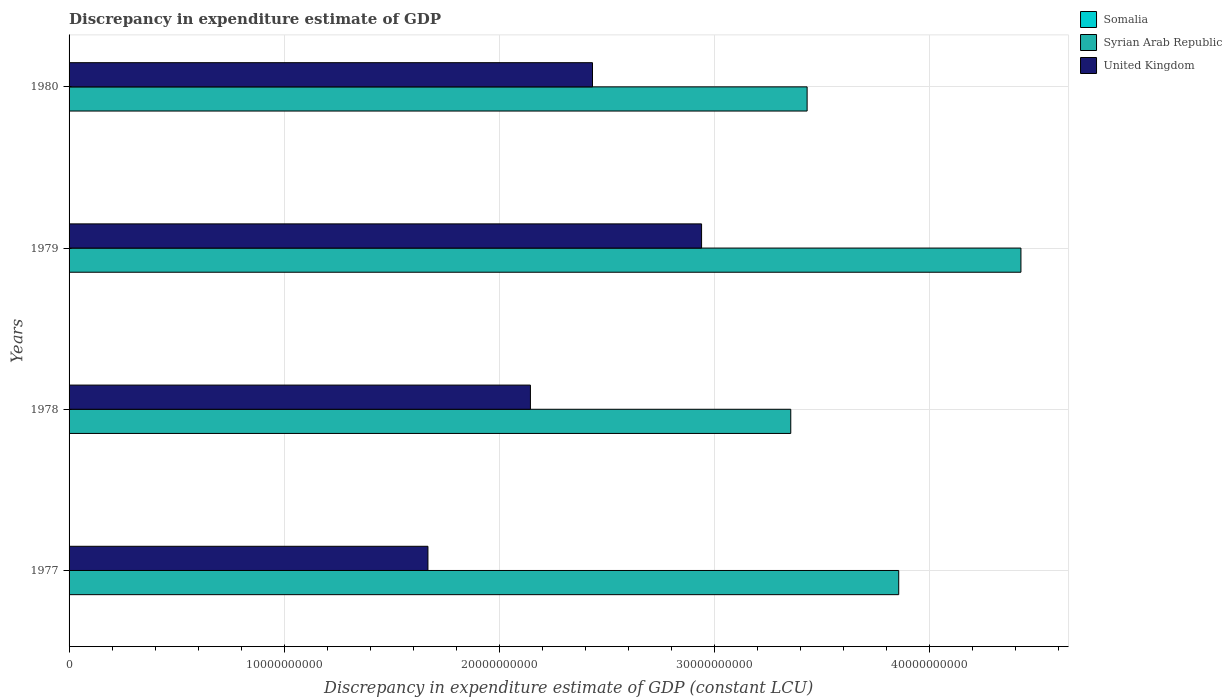How many groups of bars are there?
Keep it short and to the point. 4. Are the number of bars per tick equal to the number of legend labels?
Ensure brevity in your answer.  No. Are the number of bars on each tick of the Y-axis equal?
Make the answer very short. No. How many bars are there on the 3rd tick from the top?
Give a very brief answer. 3. How many bars are there on the 1st tick from the bottom?
Offer a very short reply. 2. What is the discrepancy in expenditure estimate of GDP in United Kingdom in 1977?
Keep it short and to the point. 1.67e+1. Across all years, what is the maximum discrepancy in expenditure estimate of GDP in Syrian Arab Republic?
Ensure brevity in your answer.  4.43e+1. Across all years, what is the minimum discrepancy in expenditure estimate of GDP in Syrian Arab Republic?
Your answer should be very brief. 3.36e+1. In which year was the discrepancy in expenditure estimate of GDP in Somalia maximum?
Your answer should be very brief. 1978. What is the total discrepancy in expenditure estimate of GDP in Syrian Arab Republic in the graph?
Your response must be concise. 1.51e+11. What is the difference between the discrepancy in expenditure estimate of GDP in Syrian Arab Republic in 1978 and that in 1979?
Keep it short and to the point. -1.07e+1. What is the difference between the discrepancy in expenditure estimate of GDP in United Kingdom in 1980 and the discrepancy in expenditure estimate of GDP in Somalia in 1978?
Offer a very short reply. 2.43e+1. What is the average discrepancy in expenditure estimate of GDP in United Kingdom per year?
Your response must be concise. 2.30e+1. In the year 1978, what is the difference between the discrepancy in expenditure estimate of GDP in Syrian Arab Republic and discrepancy in expenditure estimate of GDP in Somalia?
Offer a terse response. 3.36e+1. What is the ratio of the discrepancy in expenditure estimate of GDP in United Kingdom in 1978 to that in 1979?
Make the answer very short. 0.73. What is the difference between the highest and the second highest discrepancy in expenditure estimate of GDP in United Kingdom?
Provide a short and direct response. 5.07e+09. What is the difference between the highest and the lowest discrepancy in expenditure estimate of GDP in United Kingdom?
Your answer should be compact. 1.27e+1. How many bars are there?
Give a very brief answer. 10. Are all the bars in the graph horizontal?
Keep it short and to the point. Yes. What is the difference between two consecutive major ticks on the X-axis?
Provide a short and direct response. 1.00e+1. Are the values on the major ticks of X-axis written in scientific E-notation?
Give a very brief answer. No. Does the graph contain any zero values?
Provide a short and direct response. Yes. Where does the legend appear in the graph?
Your answer should be very brief. Top right. What is the title of the graph?
Make the answer very short. Discrepancy in expenditure estimate of GDP. Does "St. Vincent and the Grenadines" appear as one of the legend labels in the graph?
Make the answer very short. No. What is the label or title of the X-axis?
Keep it short and to the point. Discrepancy in expenditure estimate of GDP (constant LCU). What is the label or title of the Y-axis?
Provide a succinct answer. Years. What is the Discrepancy in expenditure estimate of GDP (constant LCU) in Somalia in 1977?
Your response must be concise. 0. What is the Discrepancy in expenditure estimate of GDP (constant LCU) of Syrian Arab Republic in 1977?
Your answer should be very brief. 3.86e+1. What is the Discrepancy in expenditure estimate of GDP (constant LCU) in United Kingdom in 1977?
Keep it short and to the point. 1.67e+1. What is the Discrepancy in expenditure estimate of GDP (constant LCU) of Somalia in 1978?
Offer a terse response. 1.05e+06. What is the Discrepancy in expenditure estimate of GDP (constant LCU) in Syrian Arab Republic in 1978?
Give a very brief answer. 3.36e+1. What is the Discrepancy in expenditure estimate of GDP (constant LCU) of United Kingdom in 1978?
Make the answer very short. 2.15e+1. What is the Discrepancy in expenditure estimate of GDP (constant LCU) of Somalia in 1979?
Your response must be concise. 1.01e+06. What is the Discrepancy in expenditure estimate of GDP (constant LCU) of Syrian Arab Republic in 1979?
Offer a terse response. 4.43e+1. What is the Discrepancy in expenditure estimate of GDP (constant LCU) of United Kingdom in 1979?
Your answer should be very brief. 2.94e+1. What is the Discrepancy in expenditure estimate of GDP (constant LCU) of Syrian Arab Republic in 1980?
Give a very brief answer. 3.43e+1. What is the Discrepancy in expenditure estimate of GDP (constant LCU) of United Kingdom in 1980?
Offer a terse response. 2.43e+1. Across all years, what is the maximum Discrepancy in expenditure estimate of GDP (constant LCU) in Somalia?
Offer a very short reply. 1.05e+06. Across all years, what is the maximum Discrepancy in expenditure estimate of GDP (constant LCU) of Syrian Arab Republic?
Provide a succinct answer. 4.43e+1. Across all years, what is the maximum Discrepancy in expenditure estimate of GDP (constant LCU) of United Kingdom?
Ensure brevity in your answer.  2.94e+1. Across all years, what is the minimum Discrepancy in expenditure estimate of GDP (constant LCU) of Syrian Arab Republic?
Ensure brevity in your answer.  3.36e+1. Across all years, what is the minimum Discrepancy in expenditure estimate of GDP (constant LCU) in United Kingdom?
Make the answer very short. 1.67e+1. What is the total Discrepancy in expenditure estimate of GDP (constant LCU) of Somalia in the graph?
Offer a terse response. 2.06e+06. What is the total Discrepancy in expenditure estimate of GDP (constant LCU) in Syrian Arab Republic in the graph?
Provide a succinct answer. 1.51e+11. What is the total Discrepancy in expenditure estimate of GDP (constant LCU) in United Kingdom in the graph?
Your response must be concise. 9.19e+1. What is the difference between the Discrepancy in expenditure estimate of GDP (constant LCU) in Syrian Arab Republic in 1977 and that in 1978?
Your answer should be compact. 5.02e+09. What is the difference between the Discrepancy in expenditure estimate of GDP (constant LCU) of United Kingdom in 1977 and that in 1978?
Provide a succinct answer. -4.77e+09. What is the difference between the Discrepancy in expenditure estimate of GDP (constant LCU) of Syrian Arab Republic in 1977 and that in 1979?
Your answer should be very brief. -5.68e+09. What is the difference between the Discrepancy in expenditure estimate of GDP (constant LCU) in United Kingdom in 1977 and that in 1979?
Your response must be concise. -1.27e+1. What is the difference between the Discrepancy in expenditure estimate of GDP (constant LCU) in Syrian Arab Republic in 1977 and that in 1980?
Your answer should be very brief. 4.26e+09. What is the difference between the Discrepancy in expenditure estimate of GDP (constant LCU) in United Kingdom in 1977 and that in 1980?
Your answer should be very brief. -7.65e+09. What is the difference between the Discrepancy in expenditure estimate of GDP (constant LCU) of Syrian Arab Republic in 1978 and that in 1979?
Your answer should be compact. -1.07e+1. What is the difference between the Discrepancy in expenditure estimate of GDP (constant LCU) in United Kingdom in 1978 and that in 1979?
Provide a succinct answer. -7.96e+09. What is the difference between the Discrepancy in expenditure estimate of GDP (constant LCU) in Syrian Arab Republic in 1978 and that in 1980?
Your answer should be compact. -7.61e+08. What is the difference between the Discrepancy in expenditure estimate of GDP (constant LCU) in United Kingdom in 1978 and that in 1980?
Offer a terse response. -2.89e+09. What is the difference between the Discrepancy in expenditure estimate of GDP (constant LCU) of Syrian Arab Republic in 1979 and that in 1980?
Make the answer very short. 9.94e+09. What is the difference between the Discrepancy in expenditure estimate of GDP (constant LCU) in United Kingdom in 1979 and that in 1980?
Provide a short and direct response. 5.07e+09. What is the difference between the Discrepancy in expenditure estimate of GDP (constant LCU) in Syrian Arab Republic in 1977 and the Discrepancy in expenditure estimate of GDP (constant LCU) in United Kingdom in 1978?
Keep it short and to the point. 1.71e+1. What is the difference between the Discrepancy in expenditure estimate of GDP (constant LCU) in Syrian Arab Republic in 1977 and the Discrepancy in expenditure estimate of GDP (constant LCU) in United Kingdom in 1979?
Your answer should be compact. 9.17e+09. What is the difference between the Discrepancy in expenditure estimate of GDP (constant LCU) of Syrian Arab Republic in 1977 and the Discrepancy in expenditure estimate of GDP (constant LCU) of United Kingdom in 1980?
Your answer should be very brief. 1.42e+1. What is the difference between the Discrepancy in expenditure estimate of GDP (constant LCU) of Somalia in 1978 and the Discrepancy in expenditure estimate of GDP (constant LCU) of Syrian Arab Republic in 1979?
Ensure brevity in your answer.  -4.43e+1. What is the difference between the Discrepancy in expenditure estimate of GDP (constant LCU) of Somalia in 1978 and the Discrepancy in expenditure estimate of GDP (constant LCU) of United Kingdom in 1979?
Offer a terse response. -2.94e+1. What is the difference between the Discrepancy in expenditure estimate of GDP (constant LCU) of Syrian Arab Republic in 1978 and the Discrepancy in expenditure estimate of GDP (constant LCU) of United Kingdom in 1979?
Your answer should be very brief. 4.15e+09. What is the difference between the Discrepancy in expenditure estimate of GDP (constant LCU) in Somalia in 1978 and the Discrepancy in expenditure estimate of GDP (constant LCU) in Syrian Arab Republic in 1980?
Provide a short and direct response. -3.43e+1. What is the difference between the Discrepancy in expenditure estimate of GDP (constant LCU) of Somalia in 1978 and the Discrepancy in expenditure estimate of GDP (constant LCU) of United Kingdom in 1980?
Your answer should be very brief. -2.43e+1. What is the difference between the Discrepancy in expenditure estimate of GDP (constant LCU) in Syrian Arab Republic in 1978 and the Discrepancy in expenditure estimate of GDP (constant LCU) in United Kingdom in 1980?
Keep it short and to the point. 9.22e+09. What is the difference between the Discrepancy in expenditure estimate of GDP (constant LCU) in Somalia in 1979 and the Discrepancy in expenditure estimate of GDP (constant LCU) in Syrian Arab Republic in 1980?
Keep it short and to the point. -3.43e+1. What is the difference between the Discrepancy in expenditure estimate of GDP (constant LCU) in Somalia in 1979 and the Discrepancy in expenditure estimate of GDP (constant LCU) in United Kingdom in 1980?
Keep it short and to the point. -2.43e+1. What is the difference between the Discrepancy in expenditure estimate of GDP (constant LCU) in Syrian Arab Republic in 1979 and the Discrepancy in expenditure estimate of GDP (constant LCU) in United Kingdom in 1980?
Give a very brief answer. 1.99e+1. What is the average Discrepancy in expenditure estimate of GDP (constant LCU) in Somalia per year?
Offer a very short reply. 5.15e+05. What is the average Discrepancy in expenditure estimate of GDP (constant LCU) of Syrian Arab Republic per year?
Ensure brevity in your answer.  3.77e+1. What is the average Discrepancy in expenditure estimate of GDP (constant LCU) in United Kingdom per year?
Provide a short and direct response. 2.30e+1. In the year 1977, what is the difference between the Discrepancy in expenditure estimate of GDP (constant LCU) in Syrian Arab Republic and Discrepancy in expenditure estimate of GDP (constant LCU) in United Kingdom?
Make the answer very short. 2.19e+1. In the year 1978, what is the difference between the Discrepancy in expenditure estimate of GDP (constant LCU) of Somalia and Discrepancy in expenditure estimate of GDP (constant LCU) of Syrian Arab Republic?
Provide a succinct answer. -3.36e+1. In the year 1978, what is the difference between the Discrepancy in expenditure estimate of GDP (constant LCU) in Somalia and Discrepancy in expenditure estimate of GDP (constant LCU) in United Kingdom?
Give a very brief answer. -2.15e+1. In the year 1978, what is the difference between the Discrepancy in expenditure estimate of GDP (constant LCU) of Syrian Arab Republic and Discrepancy in expenditure estimate of GDP (constant LCU) of United Kingdom?
Your answer should be very brief. 1.21e+1. In the year 1979, what is the difference between the Discrepancy in expenditure estimate of GDP (constant LCU) of Somalia and Discrepancy in expenditure estimate of GDP (constant LCU) of Syrian Arab Republic?
Ensure brevity in your answer.  -4.43e+1. In the year 1979, what is the difference between the Discrepancy in expenditure estimate of GDP (constant LCU) in Somalia and Discrepancy in expenditure estimate of GDP (constant LCU) in United Kingdom?
Your response must be concise. -2.94e+1. In the year 1979, what is the difference between the Discrepancy in expenditure estimate of GDP (constant LCU) of Syrian Arab Republic and Discrepancy in expenditure estimate of GDP (constant LCU) of United Kingdom?
Provide a succinct answer. 1.49e+1. In the year 1980, what is the difference between the Discrepancy in expenditure estimate of GDP (constant LCU) in Syrian Arab Republic and Discrepancy in expenditure estimate of GDP (constant LCU) in United Kingdom?
Offer a very short reply. 9.98e+09. What is the ratio of the Discrepancy in expenditure estimate of GDP (constant LCU) in Syrian Arab Republic in 1977 to that in 1978?
Provide a short and direct response. 1.15. What is the ratio of the Discrepancy in expenditure estimate of GDP (constant LCU) of United Kingdom in 1977 to that in 1978?
Keep it short and to the point. 0.78. What is the ratio of the Discrepancy in expenditure estimate of GDP (constant LCU) of Syrian Arab Republic in 1977 to that in 1979?
Offer a terse response. 0.87. What is the ratio of the Discrepancy in expenditure estimate of GDP (constant LCU) in United Kingdom in 1977 to that in 1979?
Your response must be concise. 0.57. What is the ratio of the Discrepancy in expenditure estimate of GDP (constant LCU) in Syrian Arab Republic in 1977 to that in 1980?
Offer a terse response. 1.12. What is the ratio of the Discrepancy in expenditure estimate of GDP (constant LCU) of United Kingdom in 1977 to that in 1980?
Your response must be concise. 0.69. What is the ratio of the Discrepancy in expenditure estimate of GDP (constant LCU) in Somalia in 1978 to that in 1979?
Make the answer very short. 1.04. What is the ratio of the Discrepancy in expenditure estimate of GDP (constant LCU) of Syrian Arab Republic in 1978 to that in 1979?
Make the answer very short. 0.76. What is the ratio of the Discrepancy in expenditure estimate of GDP (constant LCU) in United Kingdom in 1978 to that in 1979?
Your response must be concise. 0.73. What is the ratio of the Discrepancy in expenditure estimate of GDP (constant LCU) of Syrian Arab Republic in 1978 to that in 1980?
Ensure brevity in your answer.  0.98. What is the ratio of the Discrepancy in expenditure estimate of GDP (constant LCU) in United Kingdom in 1978 to that in 1980?
Make the answer very short. 0.88. What is the ratio of the Discrepancy in expenditure estimate of GDP (constant LCU) of Syrian Arab Republic in 1979 to that in 1980?
Your answer should be compact. 1.29. What is the ratio of the Discrepancy in expenditure estimate of GDP (constant LCU) in United Kingdom in 1979 to that in 1980?
Provide a short and direct response. 1.21. What is the difference between the highest and the second highest Discrepancy in expenditure estimate of GDP (constant LCU) of Syrian Arab Republic?
Keep it short and to the point. 5.68e+09. What is the difference between the highest and the second highest Discrepancy in expenditure estimate of GDP (constant LCU) in United Kingdom?
Provide a short and direct response. 5.07e+09. What is the difference between the highest and the lowest Discrepancy in expenditure estimate of GDP (constant LCU) in Somalia?
Ensure brevity in your answer.  1.05e+06. What is the difference between the highest and the lowest Discrepancy in expenditure estimate of GDP (constant LCU) of Syrian Arab Republic?
Keep it short and to the point. 1.07e+1. What is the difference between the highest and the lowest Discrepancy in expenditure estimate of GDP (constant LCU) in United Kingdom?
Provide a short and direct response. 1.27e+1. 